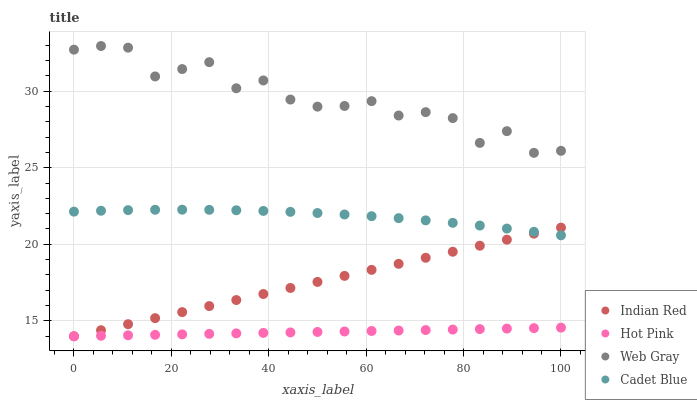Does Hot Pink have the minimum area under the curve?
Answer yes or no. Yes. Does Web Gray have the maximum area under the curve?
Answer yes or no. Yes. Does Web Gray have the minimum area under the curve?
Answer yes or no. No. Does Hot Pink have the maximum area under the curve?
Answer yes or no. No. Is Hot Pink the smoothest?
Answer yes or no. Yes. Is Web Gray the roughest?
Answer yes or no. Yes. Is Web Gray the smoothest?
Answer yes or no. No. Is Hot Pink the roughest?
Answer yes or no. No. Does Hot Pink have the lowest value?
Answer yes or no. Yes. Does Web Gray have the lowest value?
Answer yes or no. No. Does Web Gray have the highest value?
Answer yes or no. Yes. Does Hot Pink have the highest value?
Answer yes or no. No. Is Hot Pink less than Cadet Blue?
Answer yes or no. Yes. Is Cadet Blue greater than Hot Pink?
Answer yes or no. Yes. Does Indian Red intersect Hot Pink?
Answer yes or no. Yes. Is Indian Red less than Hot Pink?
Answer yes or no. No. Is Indian Red greater than Hot Pink?
Answer yes or no. No. Does Hot Pink intersect Cadet Blue?
Answer yes or no. No. 